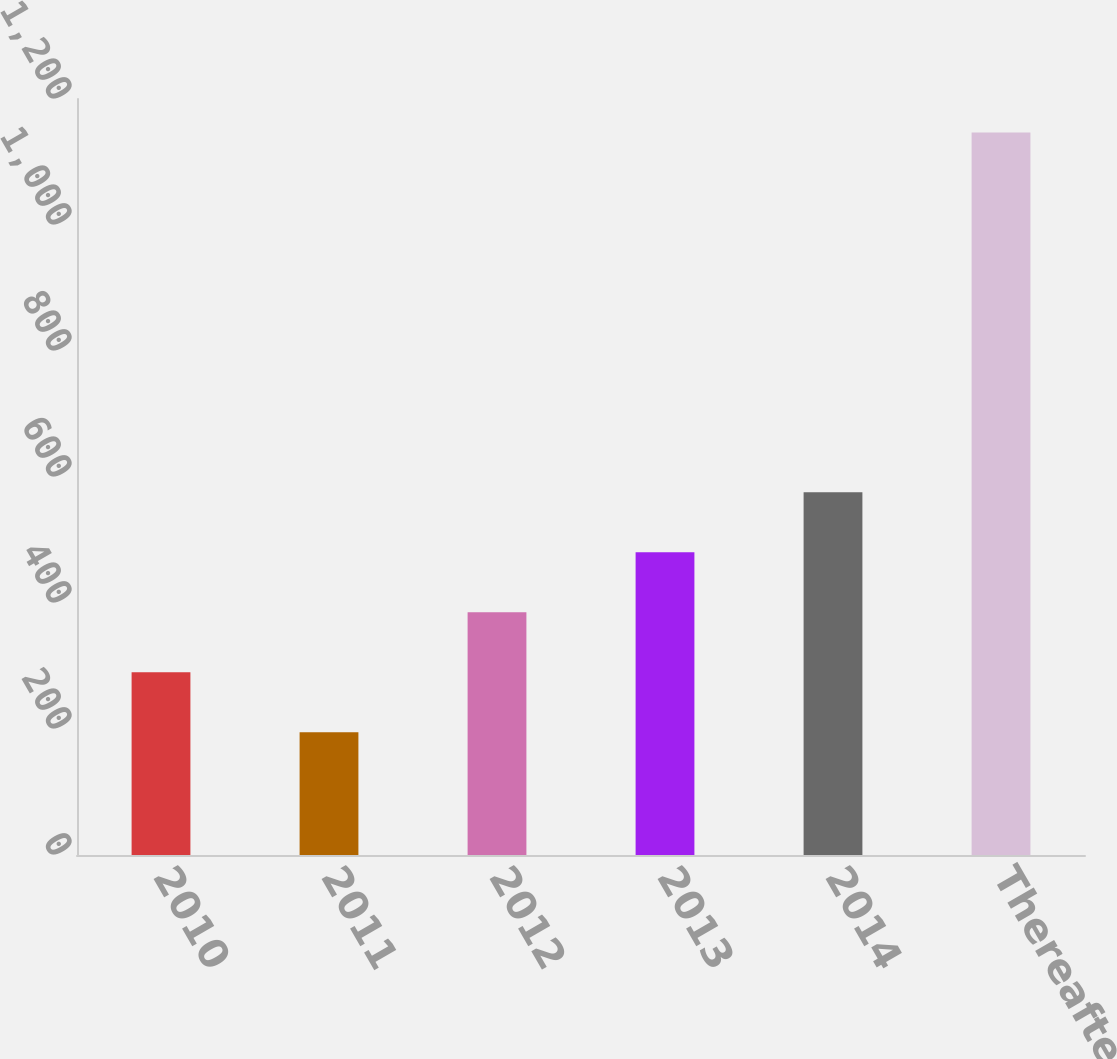<chart> <loc_0><loc_0><loc_500><loc_500><bar_chart><fcel>2010<fcel>2011<fcel>2012<fcel>2013<fcel>2014<fcel>Thereafter<nl><fcel>290.2<fcel>195<fcel>385.4<fcel>480.6<fcel>575.8<fcel>1147<nl></chart> 